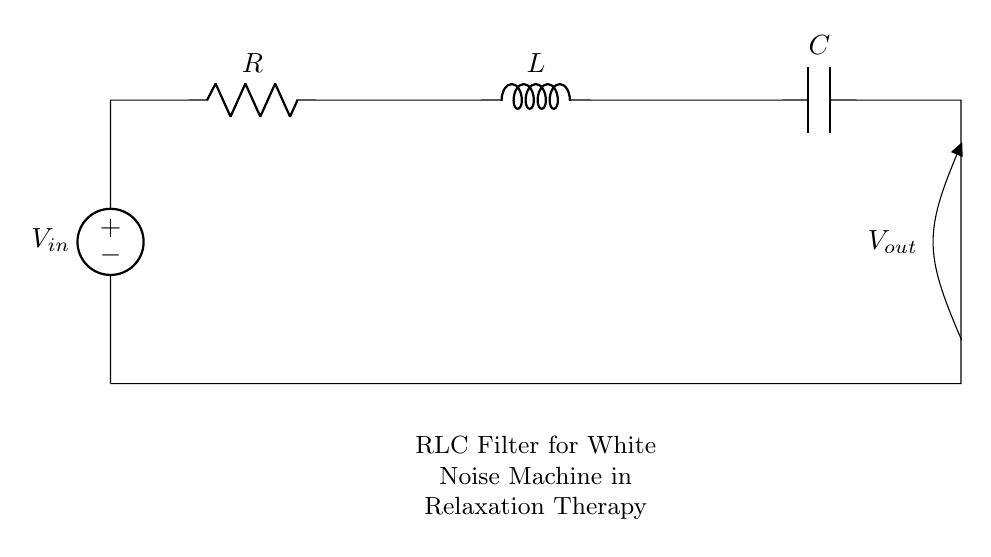What are the components in this circuit? The circuit contains a voltage source (V), a resistor (R), an inductor (L), and a capacitor (C). These components are connected sequentially.
Answer: voltage source, resistor, inductor, capacitor What is the order of components from input to output? The components are arranged in the following order from the input to output: voltage source, resistor, inductor, capacitor. This sequence determines how the electrical signals will interact.
Answer: voltage source, resistor, inductor, capacitor What is the purpose of the RLC circuit in this design? The RLC circuit serves as a filter, specifically to smooth out the white noise from the machine, allowing for a more relaxing sound profile suitable for therapy.
Answer: filtering noise Which component is responsible for energy storage in this circuit? The inductor (L) is responsible for energy storage in a magnetic field, while the capacitor (C) stores energy in an electric field. However, since the question asks for one, the capacitor is often referenced in filtering contexts.
Answer: capacitor What would happen if the resistance value is increased in this circuit? Increasing the resistance (R) would reduce the current in the circuit, which can decrease the output voltage while altering the cutoff frequency of the filter. This would affect the filtering characteristics of the RLC circuit.
Answer: reduced current What characteristic does the circuit primarily target for relaxation therapy? The circuit primarily targets the attenuation of higher frequency noise, allowing lower frequencies that promote relaxation to pass through more effectively.
Answer: attenuation of higher frequency noise What type of filter is this RLC circuit considered? This RLC circuit is considered a band-pass filter because it allows signals within a certain frequency range to pass while attenuating frequencies outside of that range.
Answer: band-pass filter 